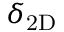<formula> <loc_0><loc_0><loc_500><loc_500>{ \delta _ { 2 D } }</formula> 